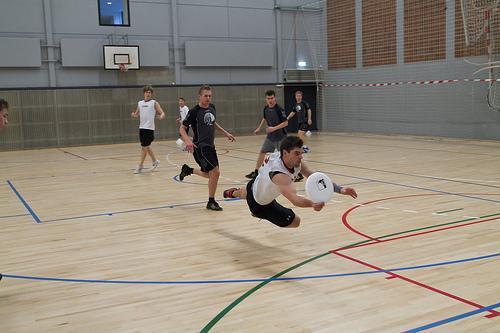How many Frisbees are there?
Give a very brief answer. 1. 